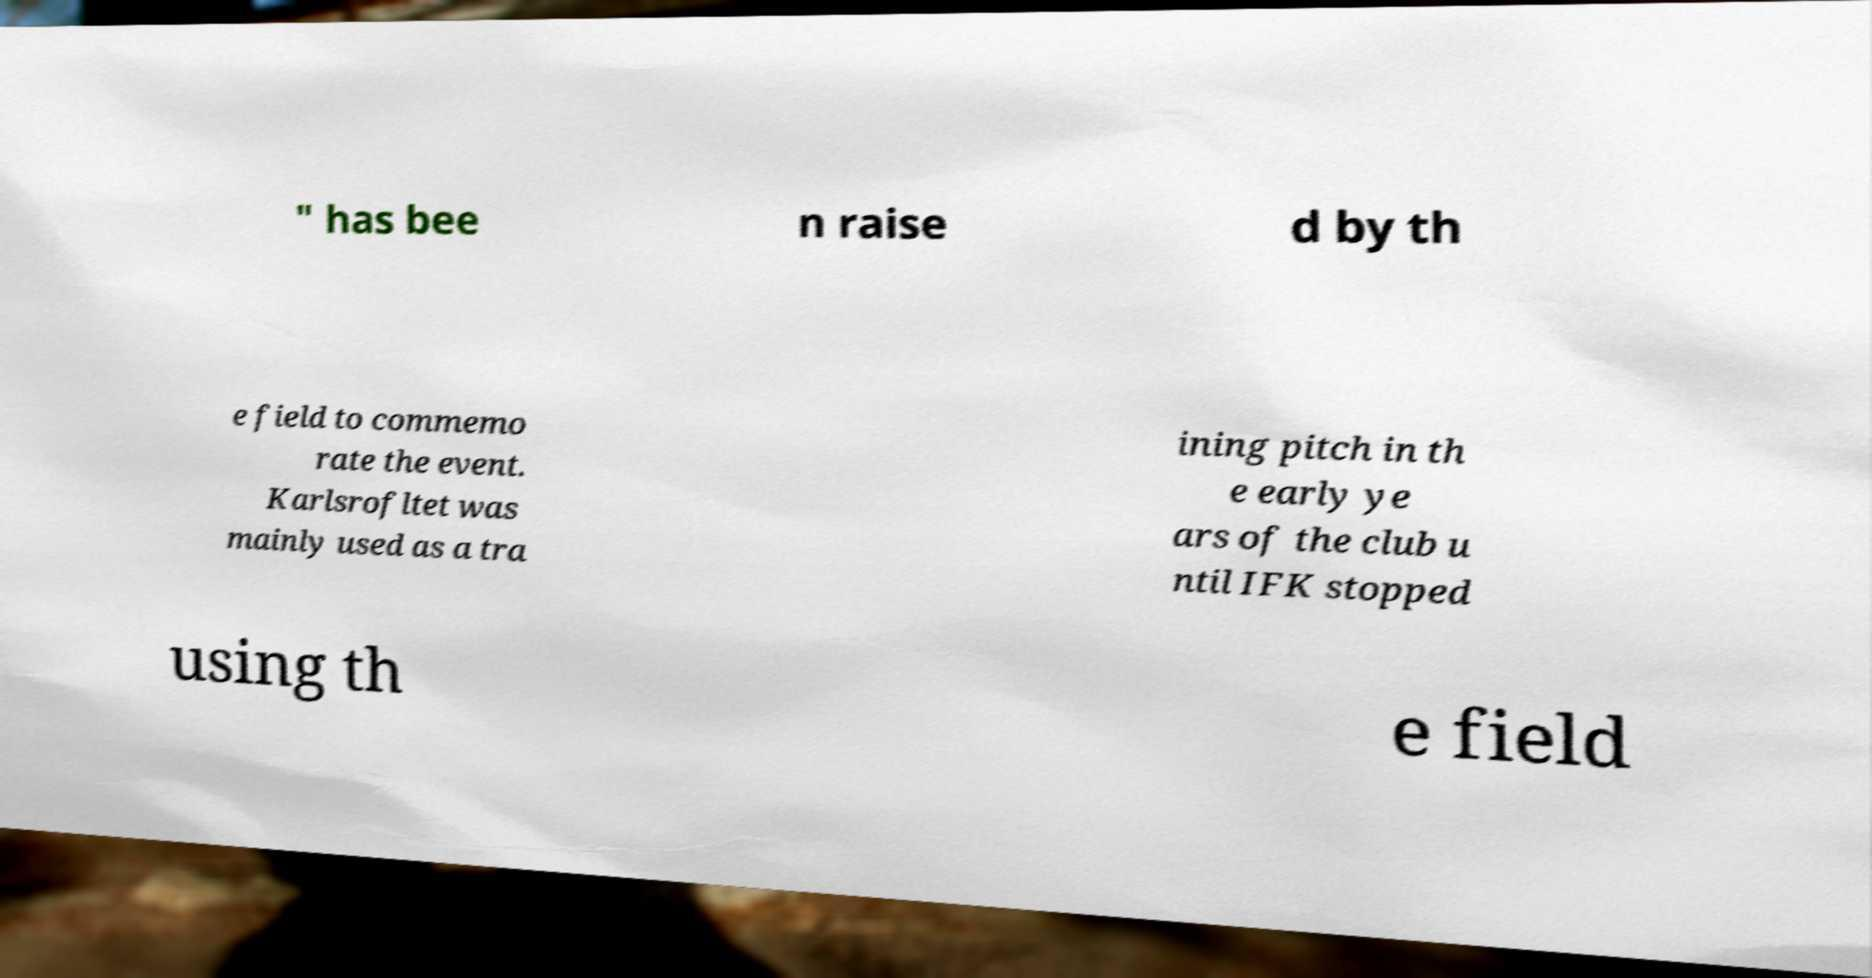Can you read and provide the text displayed in the image?This photo seems to have some interesting text. Can you extract and type it out for me? " has bee n raise d by th e field to commemo rate the event. Karlsrofltet was mainly used as a tra ining pitch in th e early ye ars of the club u ntil IFK stopped using th e field 